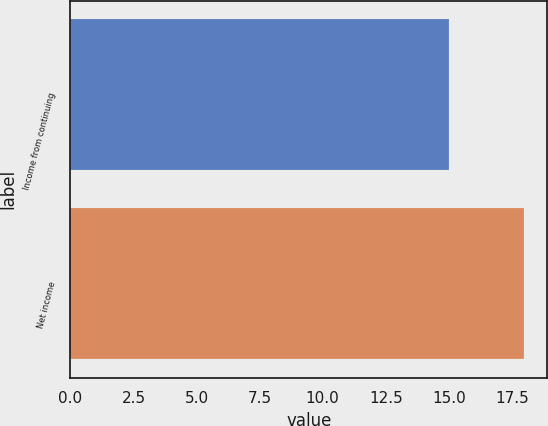Convert chart. <chart><loc_0><loc_0><loc_500><loc_500><bar_chart><fcel>Income from continuing<fcel>Net income<nl><fcel>15<fcel>18<nl></chart> 